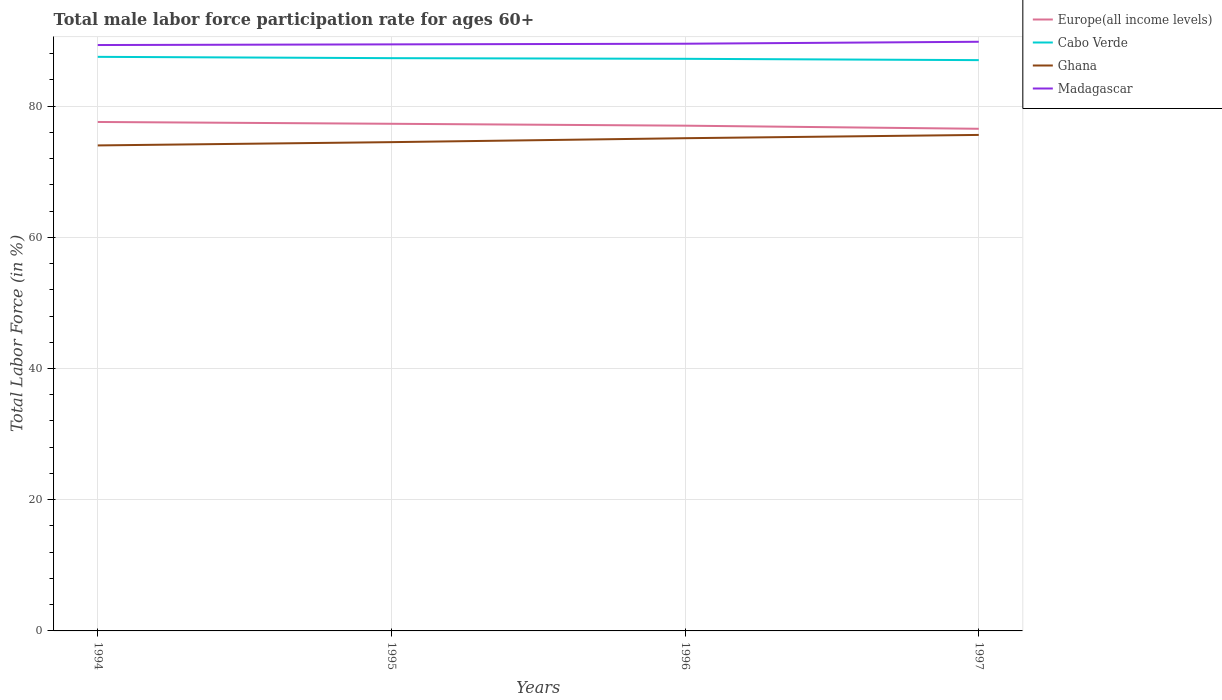How many different coloured lines are there?
Offer a terse response. 4. Does the line corresponding to Cabo Verde intersect with the line corresponding to Madagascar?
Keep it short and to the point. No. Is the number of lines equal to the number of legend labels?
Provide a short and direct response. Yes. Across all years, what is the maximum male labor force participation rate in Cabo Verde?
Give a very brief answer. 87. What is the total male labor force participation rate in Madagascar in the graph?
Make the answer very short. -0.1. What is the difference between the highest and the second highest male labor force participation rate in Madagascar?
Provide a short and direct response. 0.5. What is the difference between the highest and the lowest male labor force participation rate in Madagascar?
Ensure brevity in your answer.  1. Are the values on the major ticks of Y-axis written in scientific E-notation?
Ensure brevity in your answer.  No. Does the graph contain grids?
Make the answer very short. Yes. How are the legend labels stacked?
Your answer should be very brief. Vertical. What is the title of the graph?
Your response must be concise. Total male labor force participation rate for ages 60+. What is the label or title of the Y-axis?
Offer a terse response. Total Labor Force (in %). What is the Total Labor Force (in %) of Europe(all income levels) in 1994?
Ensure brevity in your answer.  77.57. What is the Total Labor Force (in %) of Cabo Verde in 1994?
Provide a succinct answer. 87.5. What is the Total Labor Force (in %) of Ghana in 1994?
Your answer should be compact. 74. What is the Total Labor Force (in %) in Madagascar in 1994?
Give a very brief answer. 89.3. What is the Total Labor Force (in %) in Europe(all income levels) in 1995?
Your answer should be very brief. 77.3. What is the Total Labor Force (in %) of Cabo Verde in 1995?
Your response must be concise. 87.3. What is the Total Labor Force (in %) of Ghana in 1995?
Give a very brief answer. 74.5. What is the Total Labor Force (in %) in Madagascar in 1995?
Give a very brief answer. 89.4. What is the Total Labor Force (in %) of Europe(all income levels) in 1996?
Your response must be concise. 77.01. What is the Total Labor Force (in %) of Cabo Verde in 1996?
Offer a very short reply. 87.2. What is the Total Labor Force (in %) of Ghana in 1996?
Offer a very short reply. 75.1. What is the Total Labor Force (in %) in Madagascar in 1996?
Your answer should be compact. 89.5. What is the Total Labor Force (in %) of Europe(all income levels) in 1997?
Offer a terse response. 76.54. What is the Total Labor Force (in %) of Ghana in 1997?
Offer a very short reply. 75.6. What is the Total Labor Force (in %) in Madagascar in 1997?
Make the answer very short. 89.8. Across all years, what is the maximum Total Labor Force (in %) of Europe(all income levels)?
Your answer should be compact. 77.57. Across all years, what is the maximum Total Labor Force (in %) in Cabo Verde?
Make the answer very short. 87.5. Across all years, what is the maximum Total Labor Force (in %) in Ghana?
Offer a very short reply. 75.6. Across all years, what is the maximum Total Labor Force (in %) of Madagascar?
Keep it short and to the point. 89.8. Across all years, what is the minimum Total Labor Force (in %) in Europe(all income levels)?
Provide a succinct answer. 76.54. Across all years, what is the minimum Total Labor Force (in %) in Cabo Verde?
Provide a short and direct response. 87. Across all years, what is the minimum Total Labor Force (in %) in Ghana?
Provide a short and direct response. 74. Across all years, what is the minimum Total Labor Force (in %) in Madagascar?
Offer a terse response. 89.3. What is the total Total Labor Force (in %) in Europe(all income levels) in the graph?
Ensure brevity in your answer.  308.42. What is the total Total Labor Force (in %) in Cabo Verde in the graph?
Your answer should be compact. 349. What is the total Total Labor Force (in %) in Ghana in the graph?
Your response must be concise. 299.2. What is the total Total Labor Force (in %) of Madagascar in the graph?
Provide a short and direct response. 358. What is the difference between the Total Labor Force (in %) in Europe(all income levels) in 1994 and that in 1995?
Make the answer very short. 0.28. What is the difference between the Total Labor Force (in %) of Europe(all income levels) in 1994 and that in 1996?
Your response must be concise. 0.56. What is the difference between the Total Labor Force (in %) in Ghana in 1994 and that in 1996?
Provide a succinct answer. -1.1. What is the difference between the Total Labor Force (in %) in Europe(all income levels) in 1994 and that in 1997?
Provide a short and direct response. 1.04. What is the difference between the Total Labor Force (in %) of Cabo Verde in 1994 and that in 1997?
Provide a short and direct response. 0.5. What is the difference between the Total Labor Force (in %) in Ghana in 1994 and that in 1997?
Make the answer very short. -1.6. What is the difference between the Total Labor Force (in %) in Madagascar in 1994 and that in 1997?
Offer a terse response. -0.5. What is the difference between the Total Labor Force (in %) of Europe(all income levels) in 1995 and that in 1996?
Ensure brevity in your answer.  0.29. What is the difference between the Total Labor Force (in %) in Cabo Verde in 1995 and that in 1996?
Your answer should be compact. 0.1. What is the difference between the Total Labor Force (in %) in Ghana in 1995 and that in 1996?
Ensure brevity in your answer.  -0.6. What is the difference between the Total Labor Force (in %) of Madagascar in 1995 and that in 1996?
Make the answer very short. -0.1. What is the difference between the Total Labor Force (in %) in Europe(all income levels) in 1995 and that in 1997?
Your answer should be very brief. 0.76. What is the difference between the Total Labor Force (in %) in Ghana in 1995 and that in 1997?
Keep it short and to the point. -1.1. What is the difference between the Total Labor Force (in %) in Europe(all income levels) in 1996 and that in 1997?
Give a very brief answer. 0.47. What is the difference between the Total Labor Force (in %) of Cabo Verde in 1996 and that in 1997?
Keep it short and to the point. 0.2. What is the difference between the Total Labor Force (in %) of Ghana in 1996 and that in 1997?
Provide a succinct answer. -0.5. What is the difference between the Total Labor Force (in %) of Europe(all income levels) in 1994 and the Total Labor Force (in %) of Cabo Verde in 1995?
Ensure brevity in your answer.  -9.73. What is the difference between the Total Labor Force (in %) of Europe(all income levels) in 1994 and the Total Labor Force (in %) of Ghana in 1995?
Give a very brief answer. 3.07. What is the difference between the Total Labor Force (in %) of Europe(all income levels) in 1994 and the Total Labor Force (in %) of Madagascar in 1995?
Your response must be concise. -11.83. What is the difference between the Total Labor Force (in %) in Ghana in 1994 and the Total Labor Force (in %) in Madagascar in 1995?
Your response must be concise. -15.4. What is the difference between the Total Labor Force (in %) in Europe(all income levels) in 1994 and the Total Labor Force (in %) in Cabo Verde in 1996?
Offer a terse response. -9.63. What is the difference between the Total Labor Force (in %) in Europe(all income levels) in 1994 and the Total Labor Force (in %) in Ghana in 1996?
Keep it short and to the point. 2.47. What is the difference between the Total Labor Force (in %) of Europe(all income levels) in 1994 and the Total Labor Force (in %) of Madagascar in 1996?
Keep it short and to the point. -11.93. What is the difference between the Total Labor Force (in %) in Cabo Verde in 1994 and the Total Labor Force (in %) in Ghana in 1996?
Give a very brief answer. 12.4. What is the difference between the Total Labor Force (in %) in Ghana in 1994 and the Total Labor Force (in %) in Madagascar in 1996?
Your answer should be compact. -15.5. What is the difference between the Total Labor Force (in %) of Europe(all income levels) in 1994 and the Total Labor Force (in %) of Cabo Verde in 1997?
Your answer should be very brief. -9.43. What is the difference between the Total Labor Force (in %) in Europe(all income levels) in 1994 and the Total Labor Force (in %) in Ghana in 1997?
Keep it short and to the point. 1.97. What is the difference between the Total Labor Force (in %) in Europe(all income levels) in 1994 and the Total Labor Force (in %) in Madagascar in 1997?
Your answer should be very brief. -12.23. What is the difference between the Total Labor Force (in %) of Ghana in 1994 and the Total Labor Force (in %) of Madagascar in 1997?
Your answer should be compact. -15.8. What is the difference between the Total Labor Force (in %) of Europe(all income levels) in 1995 and the Total Labor Force (in %) of Cabo Verde in 1996?
Your answer should be very brief. -9.9. What is the difference between the Total Labor Force (in %) in Europe(all income levels) in 1995 and the Total Labor Force (in %) in Ghana in 1996?
Offer a very short reply. 2.2. What is the difference between the Total Labor Force (in %) in Europe(all income levels) in 1995 and the Total Labor Force (in %) in Madagascar in 1996?
Provide a succinct answer. -12.2. What is the difference between the Total Labor Force (in %) of Cabo Verde in 1995 and the Total Labor Force (in %) of Ghana in 1996?
Give a very brief answer. 12.2. What is the difference between the Total Labor Force (in %) of Cabo Verde in 1995 and the Total Labor Force (in %) of Madagascar in 1996?
Provide a succinct answer. -2.2. What is the difference between the Total Labor Force (in %) of Ghana in 1995 and the Total Labor Force (in %) of Madagascar in 1996?
Make the answer very short. -15. What is the difference between the Total Labor Force (in %) in Europe(all income levels) in 1995 and the Total Labor Force (in %) in Cabo Verde in 1997?
Your answer should be compact. -9.7. What is the difference between the Total Labor Force (in %) of Europe(all income levels) in 1995 and the Total Labor Force (in %) of Ghana in 1997?
Provide a short and direct response. 1.7. What is the difference between the Total Labor Force (in %) in Europe(all income levels) in 1995 and the Total Labor Force (in %) in Madagascar in 1997?
Your answer should be very brief. -12.5. What is the difference between the Total Labor Force (in %) of Cabo Verde in 1995 and the Total Labor Force (in %) of Ghana in 1997?
Make the answer very short. 11.7. What is the difference between the Total Labor Force (in %) of Ghana in 1995 and the Total Labor Force (in %) of Madagascar in 1997?
Your response must be concise. -15.3. What is the difference between the Total Labor Force (in %) in Europe(all income levels) in 1996 and the Total Labor Force (in %) in Cabo Verde in 1997?
Keep it short and to the point. -9.99. What is the difference between the Total Labor Force (in %) of Europe(all income levels) in 1996 and the Total Labor Force (in %) of Ghana in 1997?
Your response must be concise. 1.41. What is the difference between the Total Labor Force (in %) in Europe(all income levels) in 1996 and the Total Labor Force (in %) in Madagascar in 1997?
Your answer should be very brief. -12.79. What is the difference between the Total Labor Force (in %) of Cabo Verde in 1996 and the Total Labor Force (in %) of Ghana in 1997?
Give a very brief answer. 11.6. What is the difference between the Total Labor Force (in %) in Cabo Verde in 1996 and the Total Labor Force (in %) in Madagascar in 1997?
Provide a short and direct response. -2.6. What is the difference between the Total Labor Force (in %) of Ghana in 1996 and the Total Labor Force (in %) of Madagascar in 1997?
Provide a succinct answer. -14.7. What is the average Total Labor Force (in %) in Europe(all income levels) per year?
Offer a very short reply. 77.1. What is the average Total Labor Force (in %) of Cabo Verde per year?
Keep it short and to the point. 87.25. What is the average Total Labor Force (in %) of Ghana per year?
Offer a very short reply. 74.8. What is the average Total Labor Force (in %) in Madagascar per year?
Your answer should be compact. 89.5. In the year 1994, what is the difference between the Total Labor Force (in %) of Europe(all income levels) and Total Labor Force (in %) of Cabo Verde?
Your response must be concise. -9.93. In the year 1994, what is the difference between the Total Labor Force (in %) of Europe(all income levels) and Total Labor Force (in %) of Ghana?
Ensure brevity in your answer.  3.57. In the year 1994, what is the difference between the Total Labor Force (in %) of Europe(all income levels) and Total Labor Force (in %) of Madagascar?
Your answer should be compact. -11.73. In the year 1994, what is the difference between the Total Labor Force (in %) in Cabo Verde and Total Labor Force (in %) in Madagascar?
Provide a short and direct response. -1.8. In the year 1994, what is the difference between the Total Labor Force (in %) in Ghana and Total Labor Force (in %) in Madagascar?
Ensure brevity in your answer.  -15.3. In the year 1995, what is the difference between the Total Labor Force (in %) of Europe(all income levels) and Total Labor Force (in %) of Cabo Verde?
Keep it short and to the point. -10. In the year 1995, what is the difference between the Total Labor Force (in %) of Europe(all income levels) and Total Labor Force (in %) of Ghana?
Offer a terse response. 2.8. In the year 1995, what is the difference between the Total Labor Force (in %) in Europe(all income levels) and Total Labor Force (in %) in Madagascar?
Provide a succinct answer. -12.1. In the year 1995, what is the difference between the Total Labor Force (in %) of Cabo Verde and Total Labor Force (in %) of Ghana?
Your response must be concise. 12.8. In the year 1995, what is the difference between the Total Labor Force (in %) in Ghana and Total Labor Force (in %) in Madagascar?
Offer a terse response. -14.9. In the year 1996, what is the difference between the Total Labor Force (in %) of Europe(all income levels) and Total Labor Force (in %) of Cabo Verde?
Offer a very short reply. -10.19. In the year 1996, what is the difference between the Total Labor Force (in %) of Europe(all income levels) and Total Labor Force (in %) of Ghana?
Provide a succinct answer. 1.91. In the year 1996, what is the difference between the Total Labor Force (in %) of Europe(all income levels) and Total Labor Force (in %) of Madagascar?
Make the answer very short. -12.49. In the year 1996, what is the difference between the Total Labor Force (in %) of Cabo Verde and Total Labor Force (in %) of Madagascar?
Ensure brevity in your answer.  -2.3. In the year 1996, what is the difference between the Total Labor Force (in %) of Ghana and Total Labor Force (in %) of Madagascar?
Your answer should be compact. -14.4. In the year 1997, what is the difference between the Total Labor Force (in %) of Europe(all income levels) and Total Labor Force (in %) of Cabo Verde?
Provide a succinct answer. -10.46. In the year 1997, what is the difference between the Total Labor Force (in %) of Europe(all income levels) and Total Labor Force (in %) of Ghana?
Your answer should be compact. 0.94. In the year 1997, what is the difference between the Total Labor Force (in %) of Europe(all income levels) and Total Labor Force (in %) of Madagascar?
Keep it short and to the point. -13.26. In the year 1997, what is the difference between the Total Labor Force (in %) of Cabo Verde and Total Labor Force (in %) of Ghana?
Give a very brief answer. 11.4. What is the ratio of the Total Labor Force (in %) in Cabo Verde in 1994 to that in 1995?
Your answer should be compact. 1. What is the ratio of the Total Labor Force (in %) in Ghana in 1994 to that in 1995?
Provide a succinct answer. 0.99. What is the ratio of the Total Labor Force (in %) in Madagascar in 1994 to that in 1995?
Offer a terse response. 1. What is the ratio of the Total Labor Force (in %) in Europe(all income levels) in 1994 to that in 1996?
Ensure brevity in your answer.  1.01. What is the ratio of the Total Labor Force (in %) of Ghana in 1994 to that in 1996?
Keep it short and to the point. 0.99. What is the ratio of the Total Labor Force (in %) of Madagascar in 1994 to that in 1996?
Offer a terse response. 1. What is the ratio of the Total Labor Force (in %) in Europe(all income levels) in 1994 to that in 1997?
Make the answer very short. 1.01. What is the ratio of the Total Labor Force (in %) in Cabo Verde in 1994 to that in 1997?
Provide a short and direct response. 1.01. What is the ratio of the Total Labor Force (in %) of Ghana in 1994 to that in 1997?
Give a very brief answer. 0.98. What is the ratio of the Total Labor Force (in %) of Europe(all income levels) in 1995 to that in 1996?
Keep it short and to the point. 1. What is the ratio of the Total Labor Force (in %) of Cabo Verde in 1995 to that in 1996?
Keep it short and to the point. 1. What is the ratio of the Total Labor Force (in %) of Madagascar in 1995 to that in 1996?
Your answer should be very brief. 1. What is the ratio of the Total Labor Force (in %) of Europe(all income levels) in 1995 to that in 1997?
Offer a terse response. 1.01. What is the ratio of the Total Labor Force (in %) of Ghana in 1995 to that in 1997?
Provide a short and direct response. 0.99. What is the ratio of the Total Labor Force (in %) of Madagascar in 1995 to that in 1997?
Your response must be concise. 1. What is the ratio of the Total Labor Force (in %) in Madagascar in 1996 to that in 1997?
Your answer should be very brief. 1. What is the difference between the highest and the second highest Total Labor Force (in %) in Europe(all income levels)?
Your answer should be very brief. 0.28. What is the difference between the highest and the lowest Total Labor Force (in %) of Europe(all income levels)?
Provide a succinct answer. 1.04. What is the difference between the highest and the lowest Total Labor Force (in %) in Cabo Verde?
Your answer should be very brief. 0.5. 